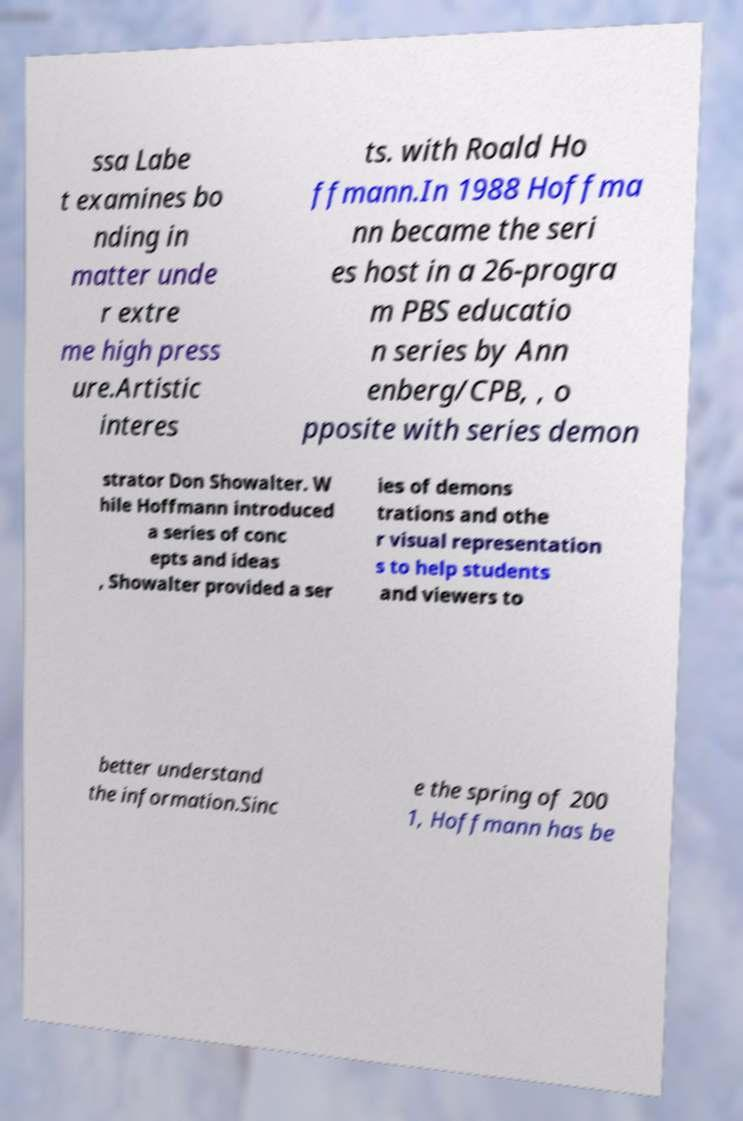Please read and relay the text visible in this image. What does it say? ssa Labe t examines bo nding in matter unde r extre me high press ure.Artistic interes ts. with Roald Ho ffmann.In 1988 Hoffma nn became the seri es host in a 26-progra m PBS educatio n series by Ann enberg/CPB, , o pposite with series demon strator Don Showalter. W hile Hoffmann introduced a series of conc epts and ideas , Showalter provided a ser ies of demons trations and othe r visual representation s to help students and viewers to better understand the information.Sinc e the spring of 200 1, Hoffmann has be 